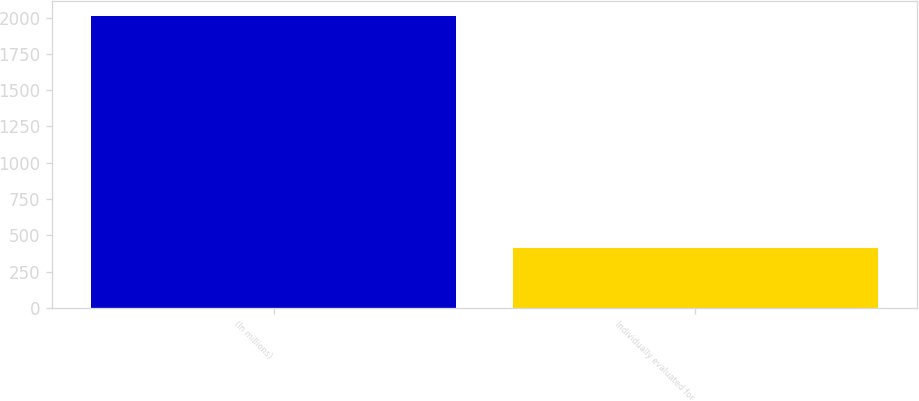Convert chart to OTSL. <chart><loc_0><loc_0><loc_500><loc_500><bar_chart><fcel>(In millions)<fcel>Individually evaluated for<nl><fcel>2012<fcel>411<nl></chart> 